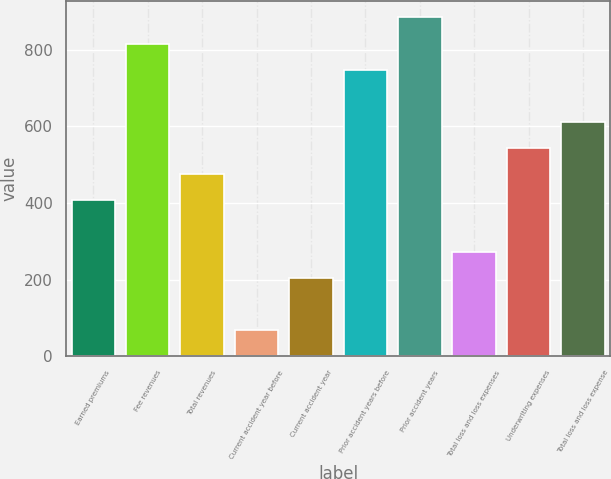<chart> <loc_0><loc_0><loc_500><loc_500><bar_chart><fcel>Earned premiums<fcel>Fee revenues<fcel>Total revenues<fcel>Current accident year before<fcel>Current accident year<fcel>Prior accident years before<fcel>Prior accident years<fcel>Total loss and loss expenses<fcel>Underwriting expenses<fcel>Total loss and loss expense<nl><fcel>408.04<fcel>815.98<fcel>476.03<fcel>68.09<fcel>204.07<fcel>747.99<fcel>883.97<fcel>272.06<fcel>544.02<fcel>612.01<nl></chart> 